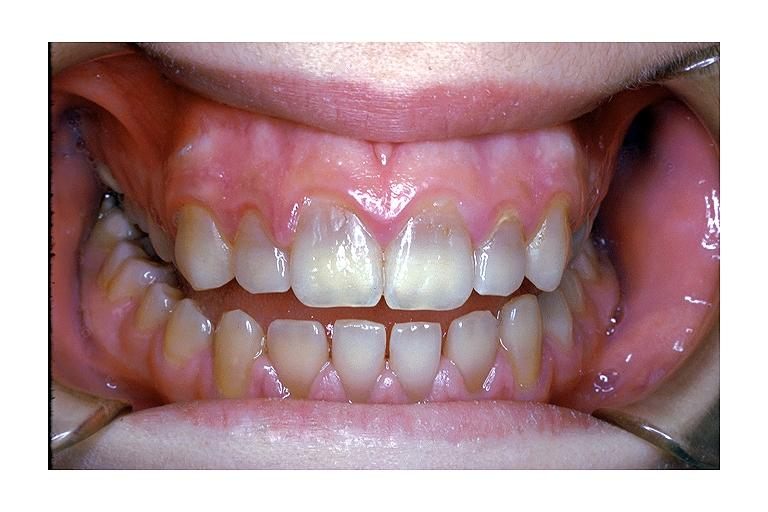what does this image show?
Answer the question using a single word or phrase. Tetracycline induced discoloration 